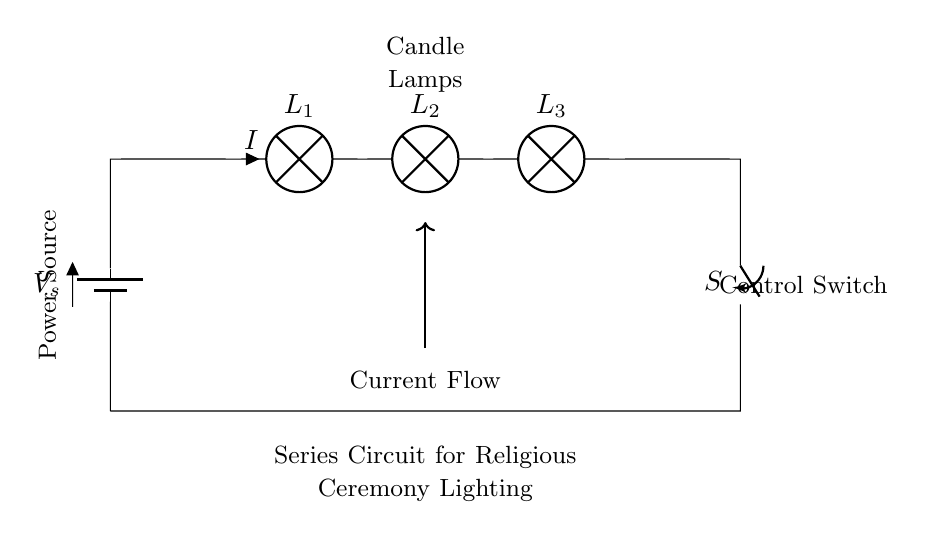What type of circuit is shown? The circuit is a series circuit, as evidenced by the components being connected end-to-end, allowing current to flow through each lamp sequentially.
Answer: Series circuit How many lamps are present in the circuit? There are three lamps, as indicated by the labels L1, L2, and L3 placed on the circuit diagram next to their symbols.
Answer: Three What is the purpose of the switch in this circuit? The switch serves to control the flow of current through the circuit. When open, it stops the current, and when closed, it allows current to reach all the lamps, enabling them to light for the ceremony.
Answer: Control current flow What happens to the other lamps if one lamp burns out? If one lamp burns out in a series circuit, the circuit is broken, and all lamps will go out since the same current flows through each lamp in series.
Answer: All lamps go out What is the function of the battery in this circuit? The battery acts as the power source, providing the necessary voltage and current to the circuit, thereby powering the lamps during the religious ceremony.
Answer: Power source What is the current value in the circuit? The current is represented by 'I', which is the same throughout the series circuit, but the exact numerical value is not specified in the diagram provided.
Answer: I 